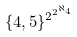Convert formula to latex. <formula><loc_0><loc_0><loc_500><loc_500>\{ 4 , 5 \} ^ { 2 ^ { 2 ^ { \aleph _ { 4 } } } }</formula> 